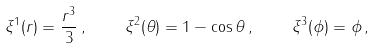<formula> <loc_0><loc_0><loc_500><loc_500>\xi ^ { 1 } ( r ) = \frac { r ^ { 3 } } { 3 } \, , \quad \xi ^ { 2 } ( \theta ) = 1 - \cos \theta \, , \quad \xi ^ { 3 } ( \phi ) = \phi \, ,</formula> 